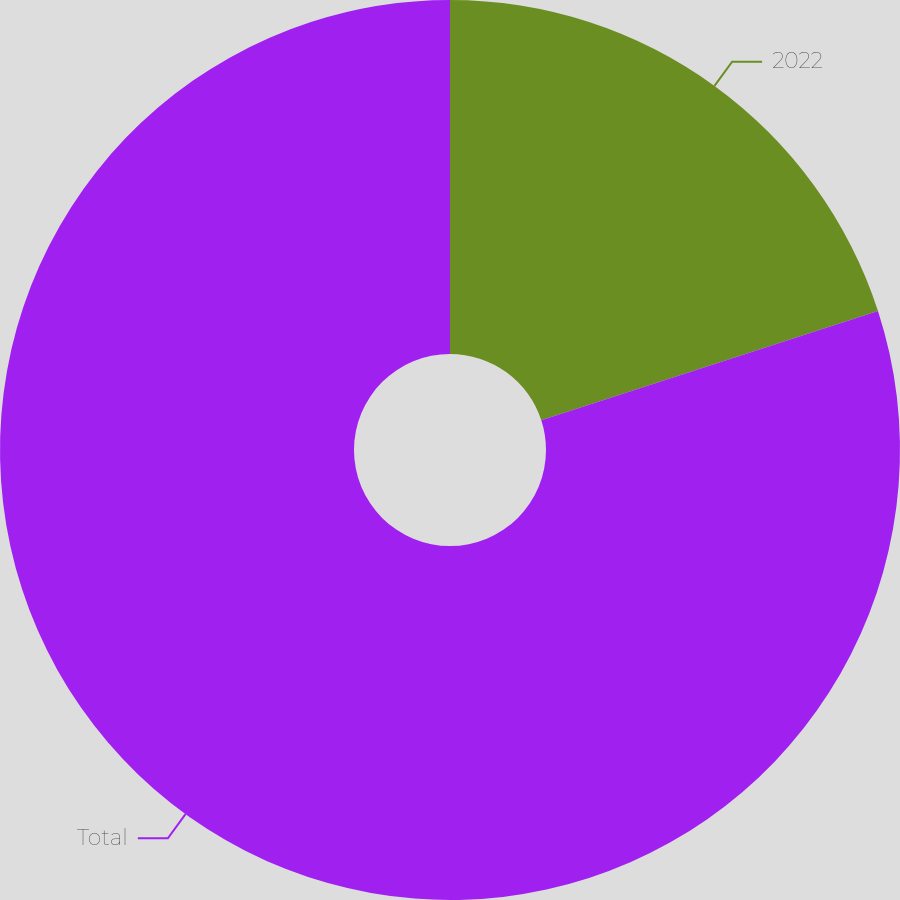<chart> <loc_0><loc_0><loc_500><loc_500><pie_chart><fcel>2022<fcel>Total<nl><fcel>20.0%<fcel>80.0%<nl></chart> 